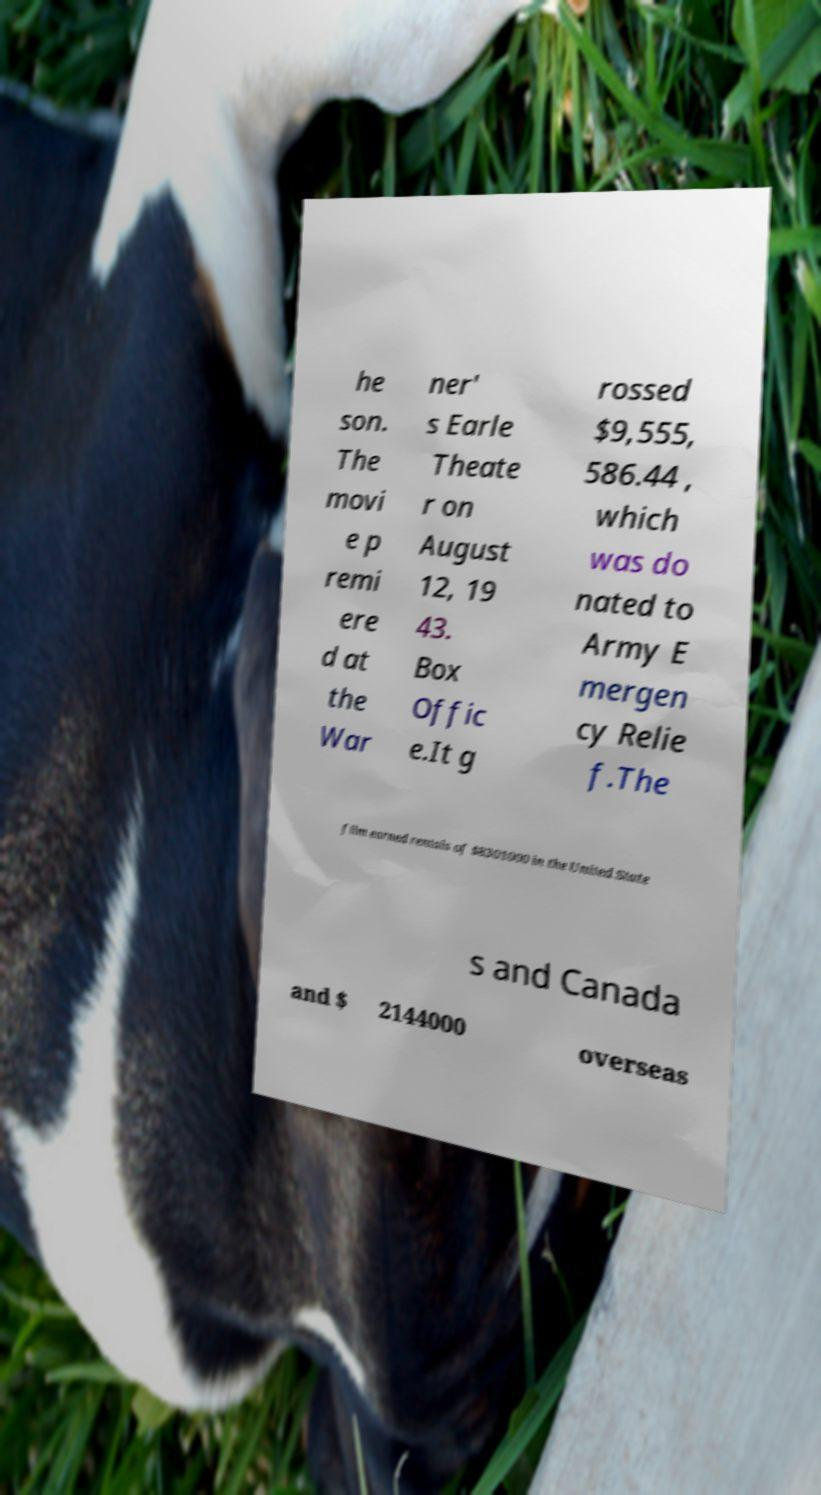There's text embedded in this image that I need extracted. Can you transcribe it verbatim? he son. The movi e p remi ere d at the War ner' s Earle Theate r on August 12, 19 43. Box Offic e.It g rossed $9,555, 586.44 , which was do nated to Army E mergen cy Relie f.The film earned rentals of $8301000 in the United State s and Canada and $ 2144000 overseas 